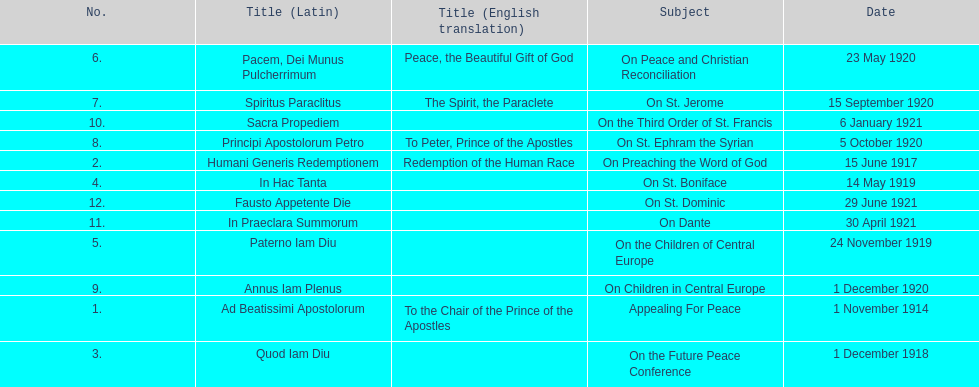What is the only subject on 23 may 1920? On Peace and Christian Reconciliation. 